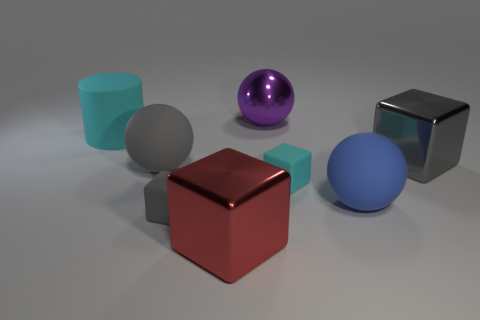Subtract 1 balls. How many balls are left? 2 Add 2 cubes. How many objects exist? 10 Subtract all cyan cubes. How many cubes are left? 3 Subtract all purple blocks. Subtract all red cylinders. How many blocks are left? 4 Subtract all cylinders. How many objects are left? 7 Subtract all metallic cubes. Subtract all gray things. How many objects are left? 3 Add 6 blue things. How many blue things are left? 7 Add 4 tiny matte blocks. How many tiny matte blocks exist? 6 Subtract 1 blue balls. How many objects are left? 7 